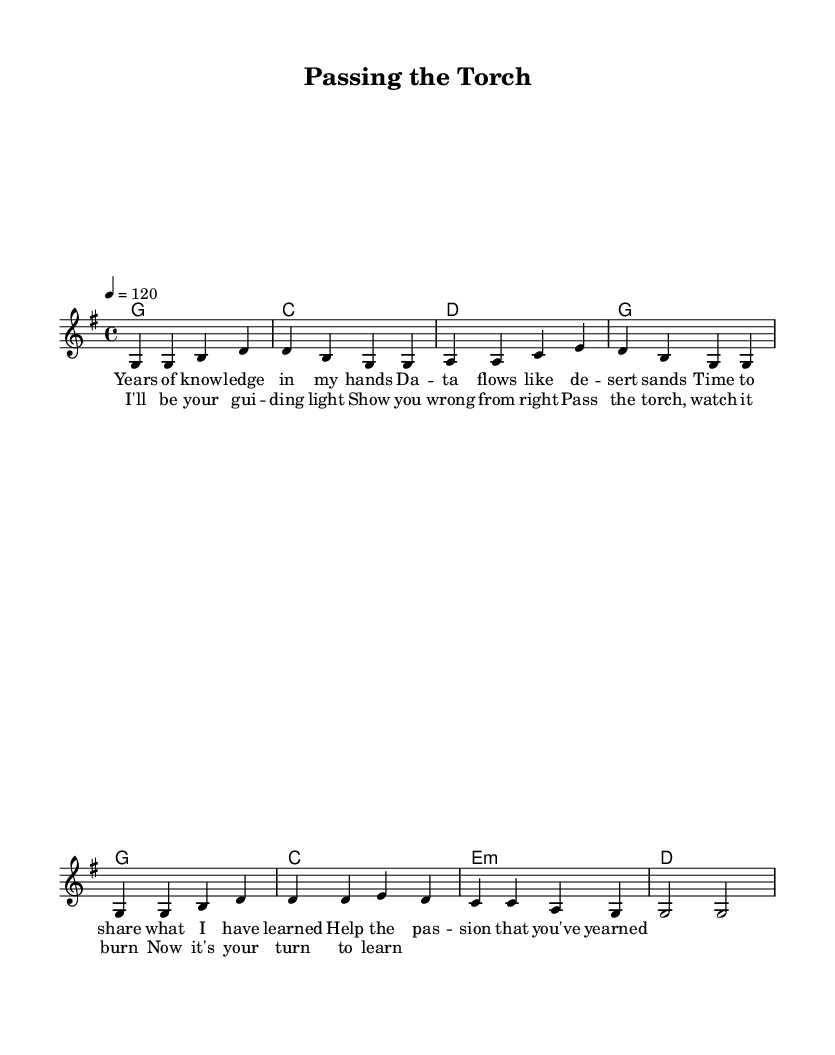What is the key signature of this music? The key signature is G major, which has one sharp (F#). This is indicated at the beginning of the score.
Answer: G major What is the time signature of this song? The time signature is 4/4, which means there are four beats in each measure and the quarter note gets one beat. This is clearly stated at the beginning of the sheet music.
Answer: 4/4 What is the tempo marking for this piece? The tempo marking indicates a tempo of quarter note equals 120 beats per minute, specified in the tempo section of the score.
Answer: 120 How many measures are in the verse? The verse consists of four measures, as can be counted from the melody, with each line containing two measures.
Answer: 4 What is the primary theme of the lyrics? The lyrics focus on mentorship and encouragement for the next generation, emphasizing the act of passing knowledge and guiding someone. This theme is reflected in both the verses and chorus.
Answer: Mentorship What is the harmony used in the chorus? The harmony used in the chorus consists of G, C, E minor, and D chords, which supports the melody throughout the chorus section.
Answer: G, C, E minor, D What lyrical structure does this song follow? The song features a verse-chorus structure, alternating between a stanza of lyrics (verse) and a repetitive theme (chorus), which is typical in country music songwriting.
Answer: Verse-chorus 